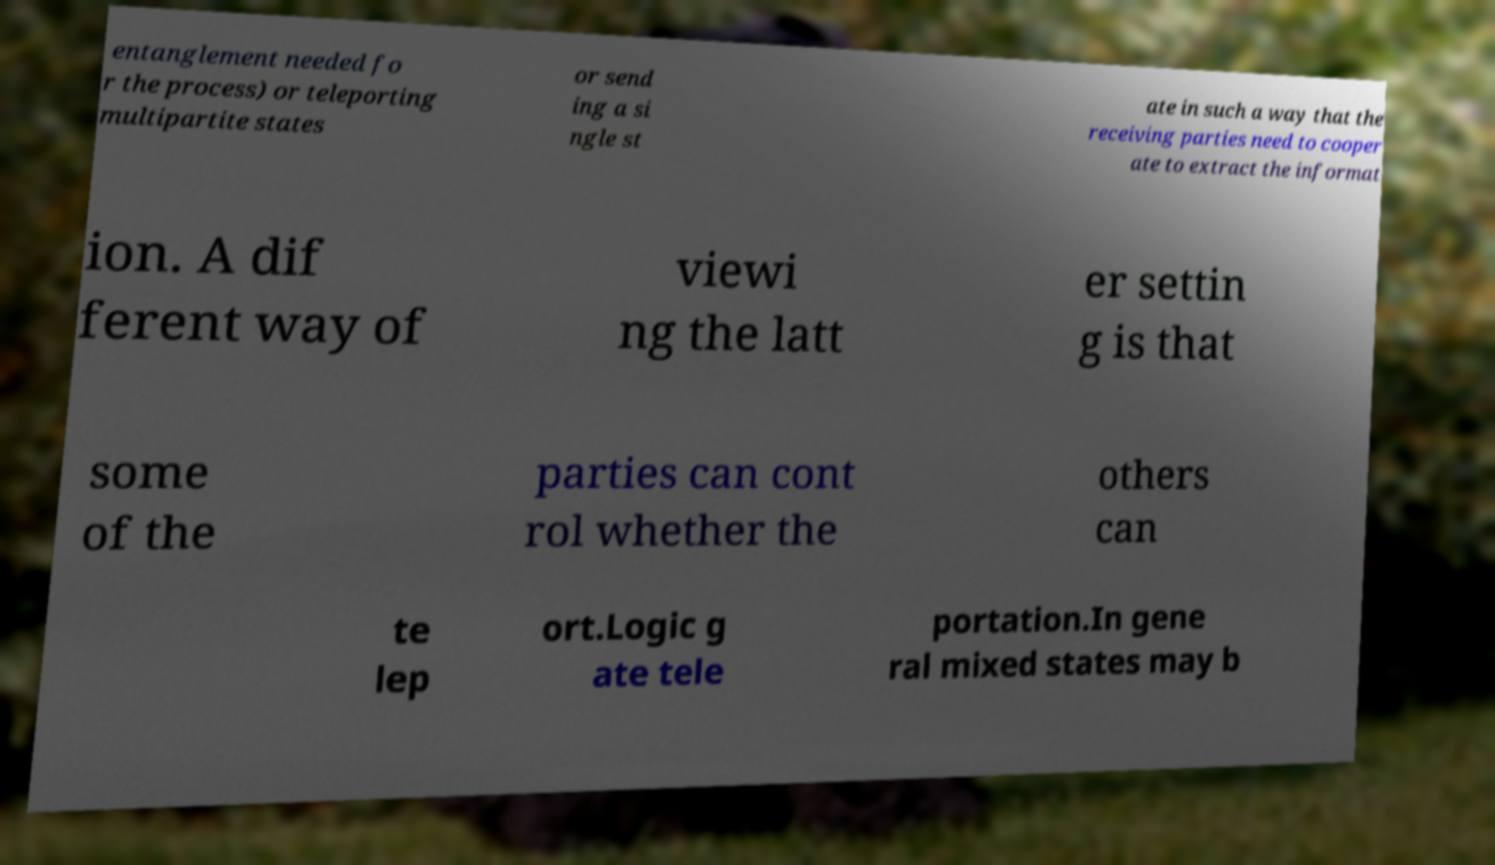Could you extract and type out the text from this image? entanglement needed fo r the process) or teleporting multipartite states or send ing a si ngle st ate in such a way that the receiving parties need to cooper ate to extract the informat ion. A dif ferent way of viewi ng the latt er settin g is that some of the parties can cont rol whether the others can te lep ort.Logic g ate tele portation.In gene ral mixed states may b 